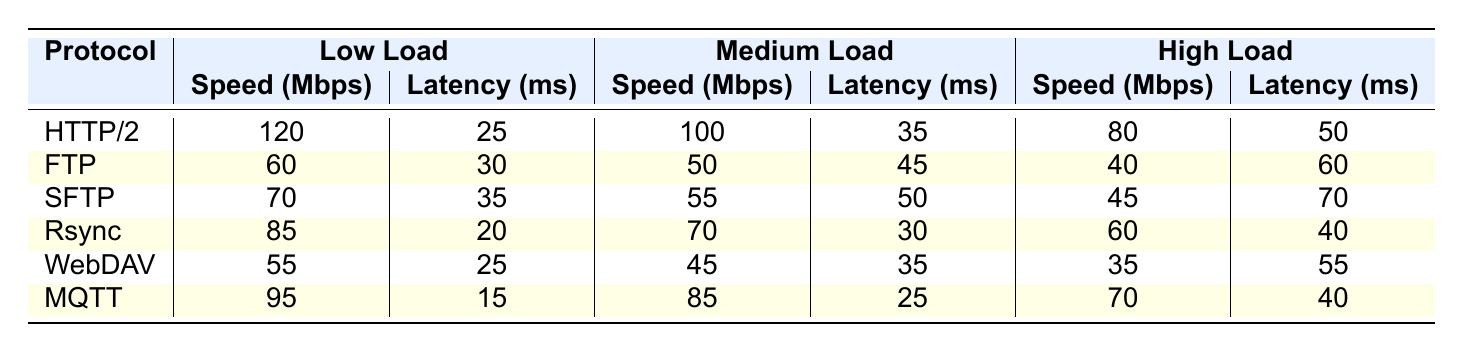What is the data transfer speed for HTTP/2 under low load? The table shows that under low load, the data transfer speed for HTTP/2 is 120 Mbps.
Answer: 120 Mbps Which protocol has the highest speed under high load? By examining the table, MQTT has the highest speed under high load at 70 Mbps, compared to the others.
Answer: MQTT What is the average data transfer speed for FTP across all load levels? Sum the speeds of FTP at low (60 Mbps), medium (50 Mbps), and high (40 Mbps) loads: 60 + 50 + 40 = 150 Mbps. Then divide by 3: 150/3 = 50 Mbps.
Answer: 50 Mbps Is the latency for SFTP under medium load less than 50 ms? The table states that SFTP under medium load has a latency of 50 ms, hence it is not less than 50 ms.
Answer: No How much slower is the speed of HTTP/2 under high load compared to low load? The speed of HTTP/2 under low load is 120 Mbps and under high load is 80 Mbps. Subtract to find the difference: 120 - 80 = 40 Mbps.
Answer: 40 Mbps Which protocol experiences the least latency under low load? Looking at the table, MQTT has the least latency under low load at 15 ms, less than all other protocols listed.
Answer: MQTT What is the speed difference between the highest and lowest protocol speeds under medium load? For medium load, HTTP/2 speed is 100 Mbps (highest) and WebDAV is 45 Mbps (lowest). The difference is 100 - 45 = 55 Mbps.
Answer: 55 Mbps Are the speeds for all protocols higher under low load compared to high load? Yes, by examining the table, all protocols show higher speeds under low load compared to high load speeds.
Answer: Yes What is the total latency for Rsync across all load levels? Sum Rsync's latencies: low (20 ms) + medium (30 ms) + high (40 ms): 20 + 30 + 40 = 90 ms.
Answer: 90 ms Which protocol has the slowest speed under high load? The table indicates that WebDAV has the slowest speed under high load at 35 Mbps.
Answer: WebDAV 